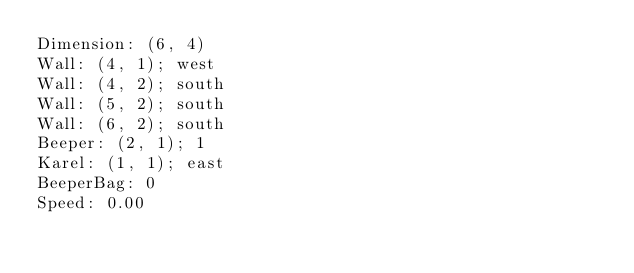Convert code to text. <code><loc_0><loc_0><loc_500><loc_500><_C_>Dimension: (6, 4)
Wall: (4, 1); west
Wall: (4, 2); south
Wall: (5, 2); south
Wall: (6, 2); south
Beeper: (2, 1); 1
Karel: (1, 1); east
BeeperBag: 0
Speed: 0.00
</code> 